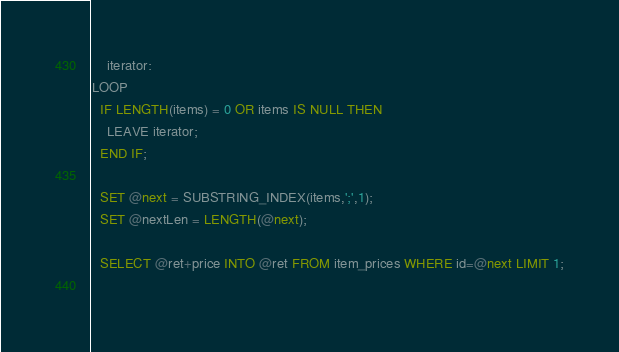Convert code to text. <code><loc_0><loc_0><loc_500><loc_500><_SQL_>    iterator:
LOOP
  IF LENGTH(items) = 0 OR items IS NULL THEN
    LEAVE iterator;
  END IF;

  SET @next = SUBSTRING_INDEX(items,';',1);
  SET @nextLen = LENGTH(@next);
  
  SELECT @ret+price INTO @ret FROM item_prices WHERE id=@next LIMIT 1;
  </code> 